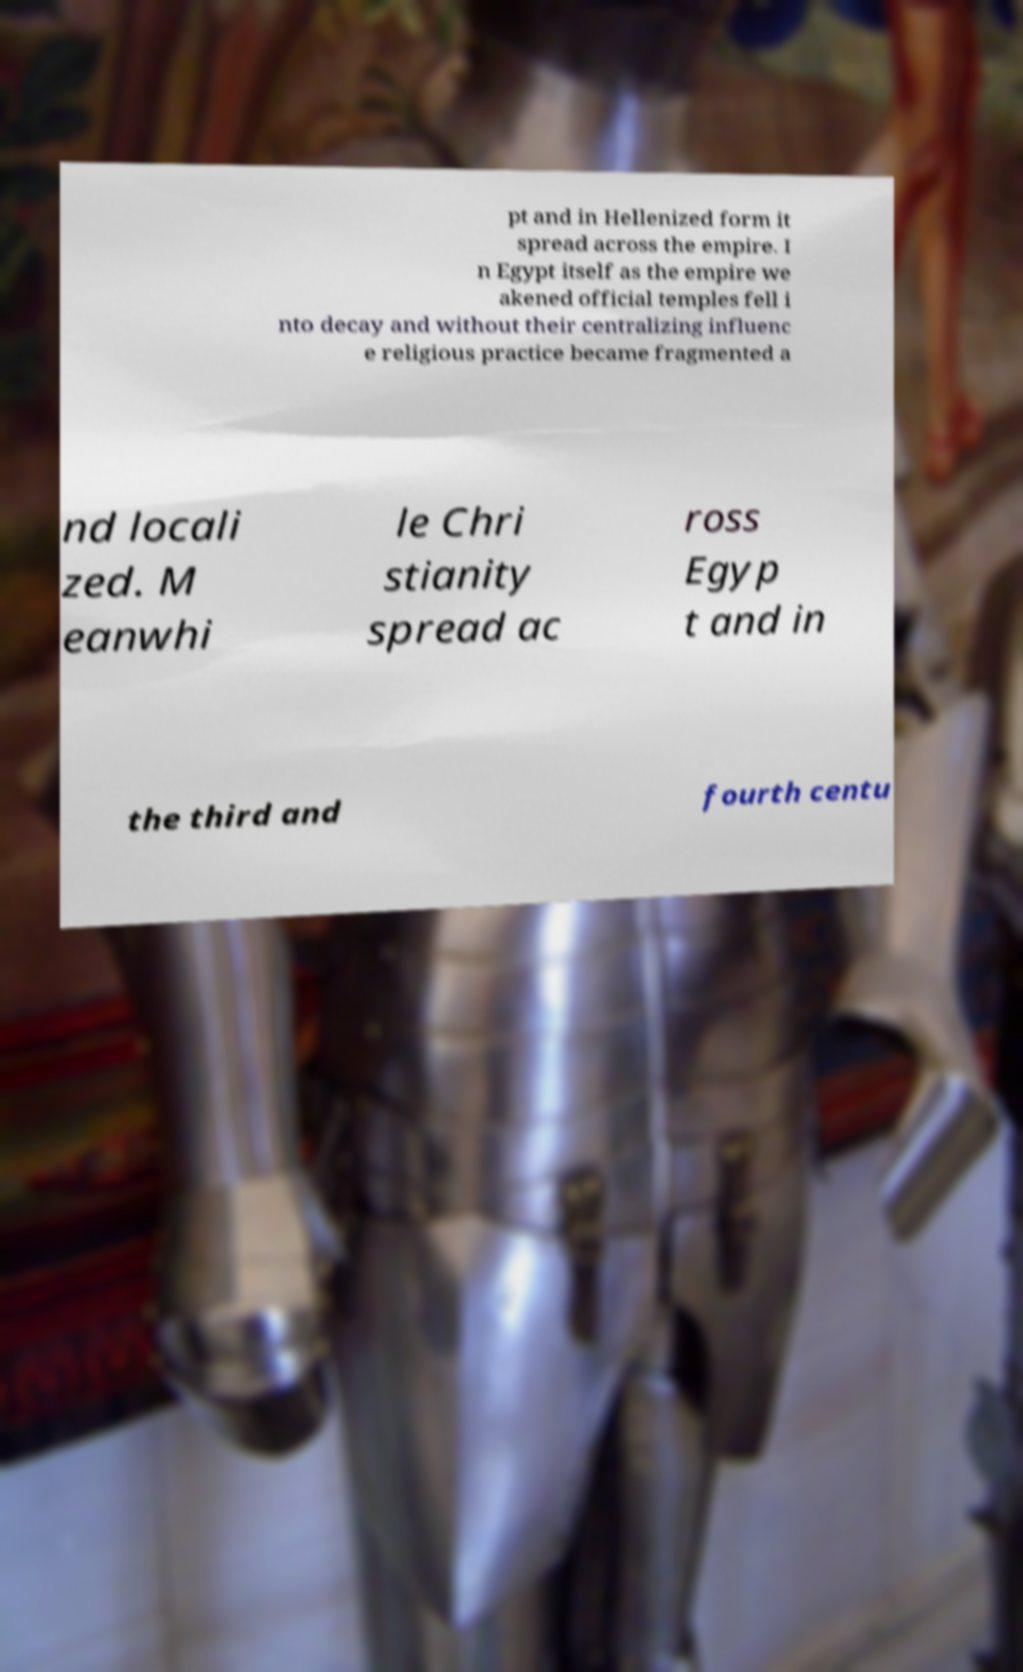Could you assist in decoding the text presented in this image and type it out clearly? pt and in Hellenized form it spread across the empire. I n Egypt itself as the empire we akened official temples fell i nto decay and without their centralizing influenc e religious practice became fragmented a nd locali zed. M eanwhi le Chri stianity spread ac ross Egyp t and in the third and fourth centu 